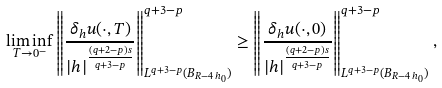Convert formula to latex. <formula><loc_0><loc_0><loc_500><loc_500>\liminf _ { T \to 0 ^ { - } } \left \| \frac { \delta _ { h } u ( \cdot , T ) } { | h | ^ { \frac { ( q + 2 - p ) s } { q + 3 - p } } } \right \| _ { L ^ { q + 3 - p } ( B _ { R - 4 \, h _ { 0 } } ) } ^ { q + 3 - p } \geq \left \| \frac { \delta _ { h } u ( \cdot , 0 ) } { | h | ^ { \frac { ( q + 2 - p ) s } { q + 3 - p } } } \right \| _ { L ^ { q + 3 - p } ( B _ { R - 4 \, h _ { 0 } } ) } ^ { q + 3 - p } ,</formula> 